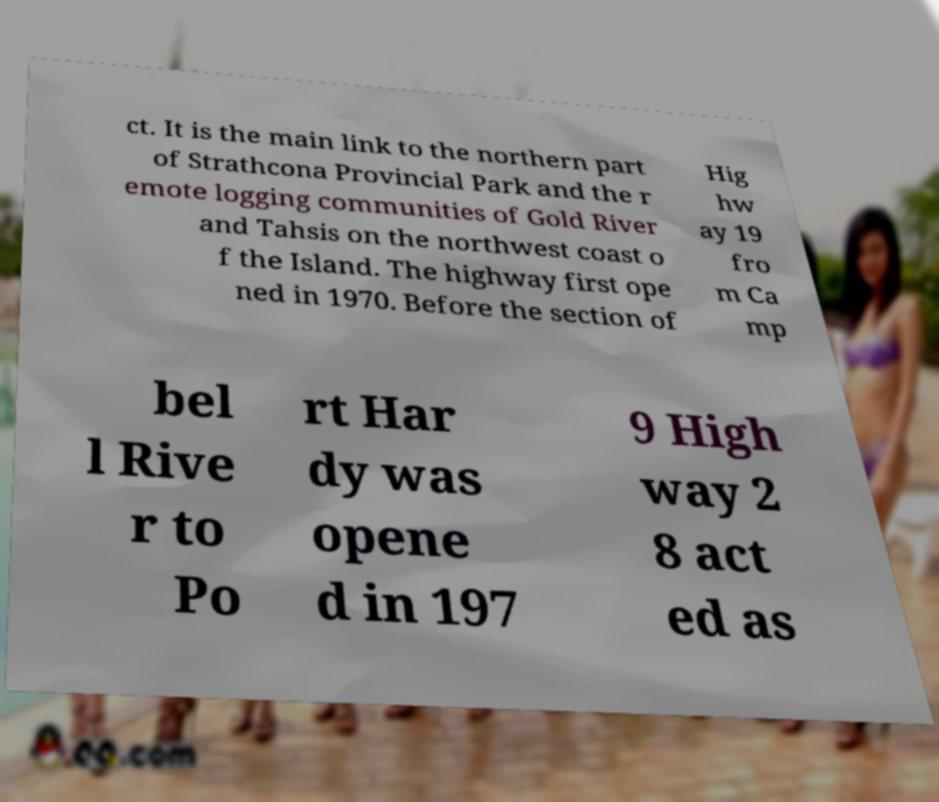I need the written content from this picture converted into text. Can you do that? ct. It is the main link to the northern part of Strathcona Provincial Park and the r emote logging communities of Gold River and Tahsis on the northwest coast o f the Island. The highway first ope ned in 1970. Before the section of Hig hw ay 19 fro m Ca mp bel l Rive r to Po rt Har dy was opene d in 197 9 High way 2 8 act ed as 